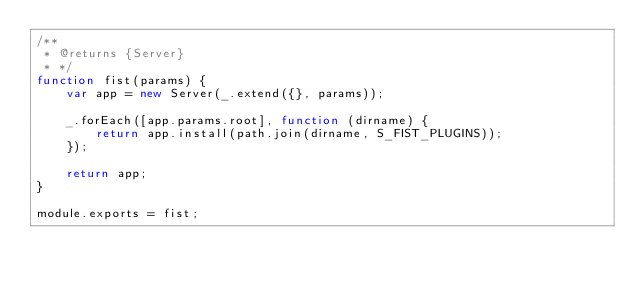Convert code to text. <code><loc_0><loc_0><loc_500><loc_500><_JavaScript_>/**
 * @returns {Server}
 * */
function fist(params) {
    var app = new Server(_.extend({}, params));

    _.forEach([app.params.root], function (dirname) {
        return app.install(path.join(dirname, S_FIST_PLUGINS));
    });

    return app;
}

module.exports = fist;
</code> 